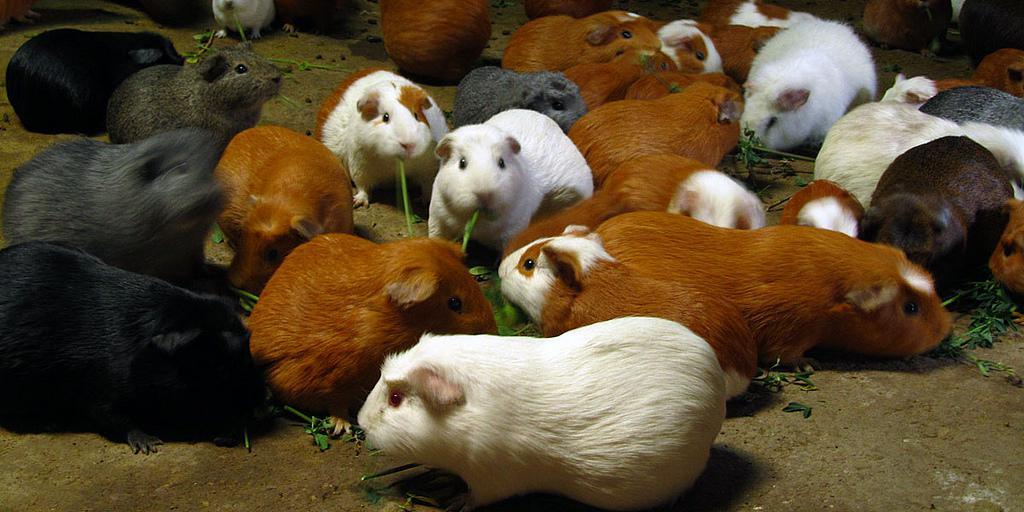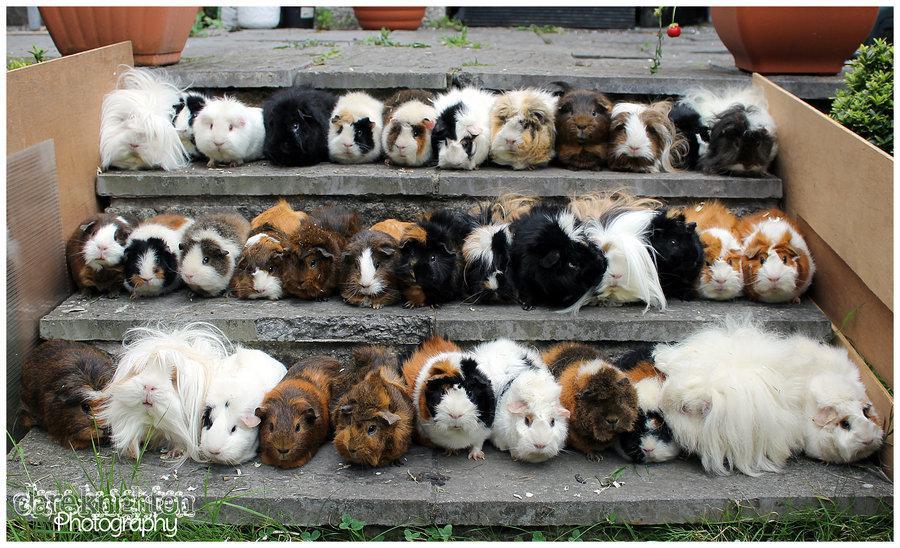The first image is the image on the left, the second image is the image on the right. For the images displayed, is the sentence "At least one image shows guinea pigs lined up on three steps." factually correct? Answer yes or no. Yes. 